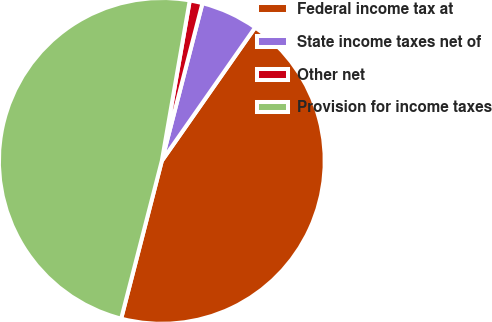<chart> <loc_0><loc_0><loc_500><loc_500><pie_chart><fcel>Federal income tax at<fcel>State income taxes net of<fcel>Other net<fcel>Provision for income taxes<nl><fcel>44.3%<fcel>5.7%<fcel>1.27%<fcel>48.73%<nl></chart> 